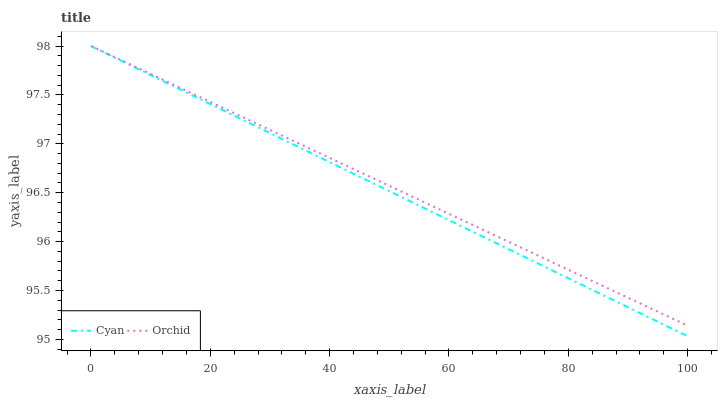Does Orchid have the minimum area under the curve?
Answer yes or no. No. Is Orchid the smoothest?
Answer yes or no. No. Does Orchid have the lowest value?
Answer yes or no. No. 